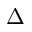<formula> <loc_0><loc_0><loc_500><loc_500>\Delta</formula> 